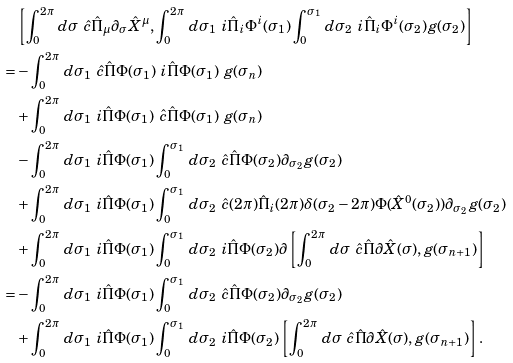<formula> <loc_0><loc_0><loc_500><loc_500>& \left [ \int _ { 0 } ^ { 2 \pi } \, d \sigma \ \hat { c } \hat { \Pi } _ { \mu } \partial _ { \sigma } \hat { X } ^ { \mu } , \int _ { 0 } ^ { 2 \pi } \, d \sigma _ { 1 } \ i \hat { \Pi } _ { i } \Phi ^ { i } ( \sigma _ { 1 } ) \int _ { 0 } ^ { \sigma _ { 1 } } \, d \sigma _ { 2 } \ i \hat { \Pi } _ { i } \Phi ^ { i } ( \sigma _ { 2 } ) g ( \sigma _ { 2 } ) \right ] \\ = & - \int _ { 0 } ^ { 2 \pi } \, d \sigma _ { 1 } \ \hat { c } \hat { \Pi } \Phi ( \sigma _ { 1 } ) \ i \hat { \Pi } \Phi ( \sigma _ { 1 } ) \ g ( \sigma _ { n } ) \\ & + \int _ { 0 } ^ { 2 \pi } \, d \sigma _ { 1 } \ i \hat { \Pi } \Phi ( \sigma _ { 1 } ) \ \hat { c } \hat { \Pi } \Phi ( \sigma _ { 1 } ) \ g ( \sigma _ { n } ) \\ & - \int _ { 0 } ^ { 2 \pi } \, d \sigma _ { 1 } \ i \hat { \Pi } \Phi ( \sigma _ { 1 } ) \int _ { 0 } ^ { \sigma _ { 1 } } \, d \sigma _ { 2 } \ \hat { c } \hat { \Pi } \Phi ( \sigma _ { 2 } ) \partial _ { \sigma _ { 2 } } g ( \sigma _ { 2 } ) \\ & + \int _ { 0 } ^ { 2 \pi } \, d \sigma _ { 1 } \ i \hat { \Pi } \Phi ( \sigma _ { 1 } ) \int _ { 0 } ^ { \sigma _ { 1 } } \, d \sigma _ { 2 } \ \hat { c } ( 2 \pi ) \hat { \Pi } _ { i } ( 2 \pi ) \delta ( \sigma _ { 2 } - 2 \pi ) \Phi ( \hat { X } ^ { 0 } ( \sigma _ { 2 } ) ) \partial _ { \sigma _ { 2 } } g ( \sigma _ { 2 } ) \\ & + \int _ { 0 } ^ { 2 \pi } \, d \sigma _ { 1 } \ i \hat { \Pi } \Phi ( \sigma _ { 1 } ) \int _ { 0 } ^ { \sigma _ { 1 } } \, d \sigma _ { 2 } \ i \hat { \Pi } \Phi ( \sigma _ { 2 } ) \partial \left [ \int _ { 0 } ^ { 2 \pi } \, d \sigma \ \hat { c } \hat { \Pi } \partial \hat { X } ( \sigma ) , g ( \sigma _ { n + 1 } ) \right ] \\ = & - \int _ { 0 } ^ { 2 \pi } \, d \sigma _ { 1 } \ i \hat { \Pi } \Phi ( \sigma _ { 1 } ) \int _ { 0 } ^ { \sigma _ { 1 } } \, d \sigma _ { 2 } \ \hat { c } \hat { \Pi } \Phi ( \sigma _ { 2 } ) \partial _ { \sigma _ { 2 } } g ( \sigma _ { 2 } ) \\ & + \int _ { 0 } ^ { 2 \pi } \, d \sigma _ { 1 } \ i \hat { \Pi } \Phi ( \sigma _ { 1 } ) \int _ { 0 } ^ { \sigma _ { 1 } } \, d \sigma _ { 2 } \ i \hat { \Pi } \Phi ( \sigma _ { 2 } ) \left [ \int _ { 0 } ^ { 2 \pi } \, d \sigma \ \hat { c } \hat { \Pi } \partial \hat { X } ( \sigma ) , g ( \sigma _ { n + 1 } ) \right ] .</formula> 